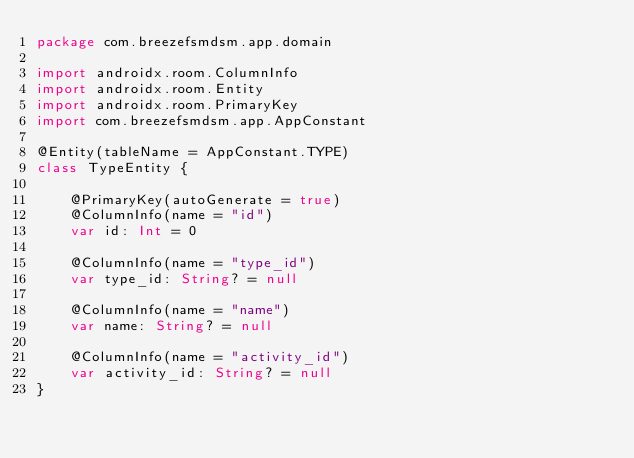Convert code to text. <code><loc_0><loc_0><loc_500><loc_500><_Kotlin_>package com.breezefsmdsm.app.domain

import androidx.room.ColumnInfo
import androidx.room.Entity
import androidx.room.PrimaryKey
import com.breezefsmdsm.app.AppConstant

@Entity(tableName = AppConstant.TYPE)
class TypeEntity {

    @PrimaryKey(autoGenerate = true)
    @ColumnInfo(name = "id")
    var id: Int = 0

    @ColumnInfo(name = "type_id")
    var type_id: String? = null

    @ColumnInfo(name = "name")
    var name: String? = null

    @ColumnInfo(name = "activity_id")
    var activity_id: String? = null
}</code> 